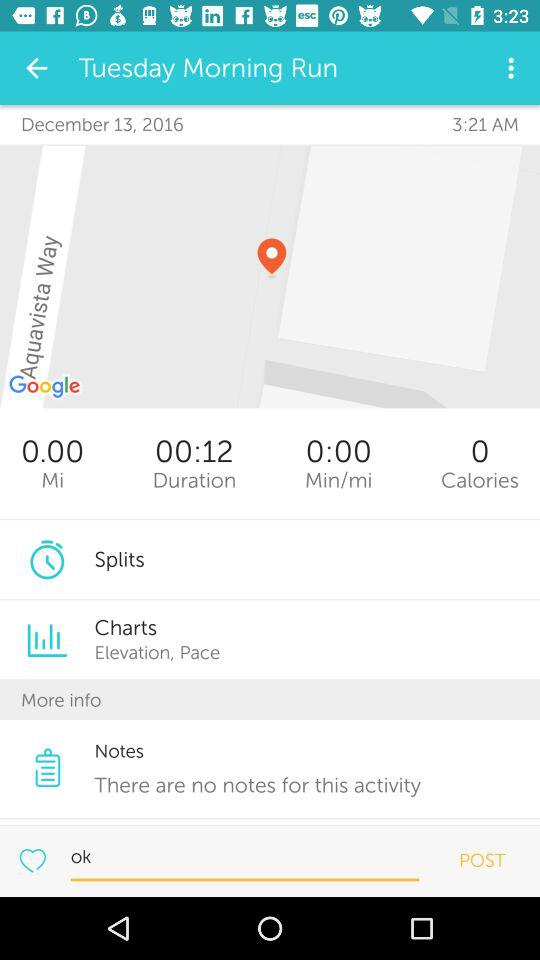How many calories are there? There are 0 calories. 